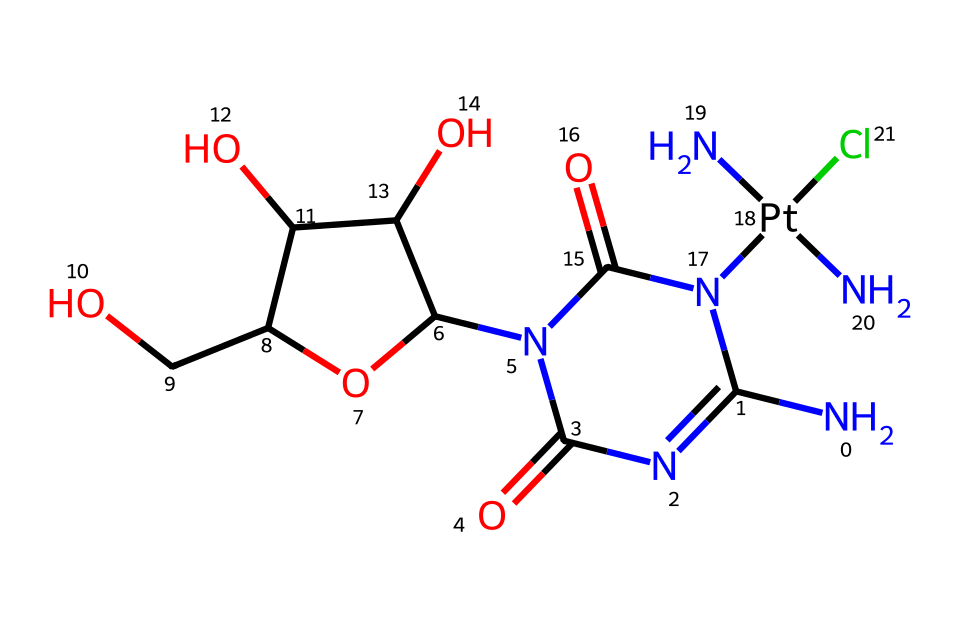How many nitrogen atoms are present in this chemical structure? The SMILES representation includes multiple nitrogen (N) atoms. By counting the occurrences of 'N' in the representation, we find three nitrogen atoms.
Answer: three What is the central metal atom in this complex? The 'Pt' in the SMILES string indicates that platinum is the central metal atom in this chemical structure.
Answer: platinum What functional group is represented by the 'N(C)(C)' portion of the structure? The notation 'N(C)(C)' signifies a tertiary amine as it has three substituents attached to the nitrogen atom, distinguishing it from primary and secondary amines.
Answer: tertiary amine How does the presence of chlorine influence the solubility of this compound? Chlorine, being a halogen, can enhance the compound's solubility in polar solvents due to its ability to associate with solvent molecules, making it more soluble.
Answer: enhances solubility What type of bond is formed between the platinum and the ligands in this drug? The bonds between platinum and its ligands are coordinate covalent bonds, as the ligands donate pairs of electrons to the metal atom forming stable complexes.
Answer: coordinate covalent bonds What is the total number of oxygen atoms present? In the SMILES structure, the letter 'O' stands for oxygen; counting these instances reveals there are three oxygen atoms present in the molecule.
Answer: three 